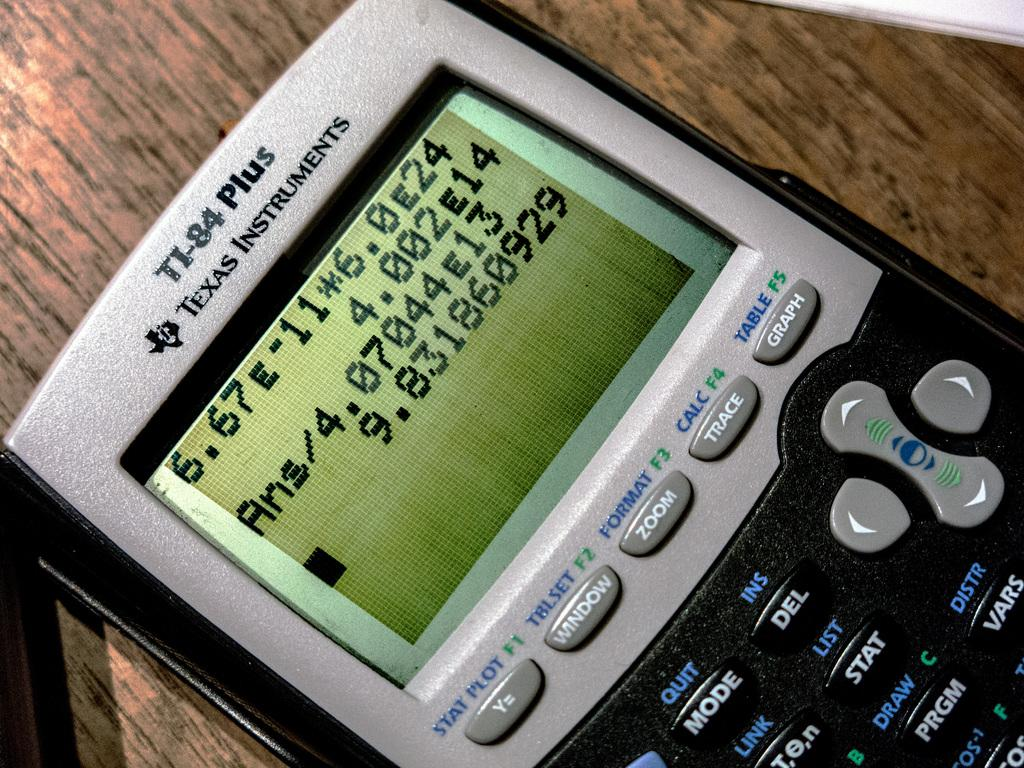<image>
Share a concise interpretation of the image provided. A texas instruments calculator, its model number it TI-84 plus. 